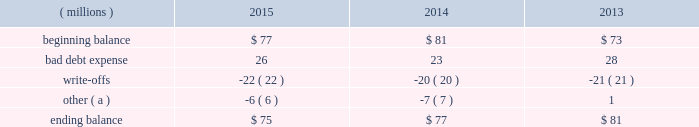Concentration of credit risk credit risk represents the accounting loss that would be recognized at the reporting date if counterparties failed to perform as contracted .
The company believes the likelihood of incurring material losses due to concentration of credit risk is remote .
The principal financial instruments subject to credit risk are as follows : cash and cash equivalents - the company maintains cash deposits with major banks , which from time to time may exceed insured limits .
The possibility of loss related to financial condition of major banks has been deemed minimal .
Additionally , the company 2019s investment policy limits exposure to concentrations of credit risk and changes in market conditions .
Accounts receivable - a large number of customers in diverse industries and geographies , as well as the practice of establishing reasonable credit lines , limits credit risk .
Based on historical trends and experiences , the allowance for doubtful accounts is adequate to cover potential credit risk losses .
Foreign currency and interest rate contracts and derivatives - exposure to credit risk is limited by internal policies and active monitoring of counterparty risks .
In addition , the company uses a diversified group of major international banks and financial institutions as counterparties .
The company does not anticipate nonperformance by any of these counterparties .
Cash and cash equivalents cash equivalents include highly-liquid investments with a maturity of three months or less when purchased .
Accounts receivable and allowance for doubtful accounts accounts receivable are carried at their face amounts less an allowance for doubtful accounts .
Accounts receivable are recorded at the invoiced amount and generally do not bear interest .
The company estimates the balance of allowance for doubtful accounts by analyzing accounts receivable balances by age and applying historical write-off and collection trend rates .
The company 2019s estimates include separately providing for customer balances based on specific circumstances and credit conditions , and when it is deemed probable that the balance is uncollectible .
Account balances are charged off against the allowance when it is determined the receivable will not be recovered .
The company 2019s allowance for doubtful accounts balance also includes an allowance for the expected return of products shipped and credits related to pricing or quantities shipped of $ 15 million as of december 31 , 2015 and 2014 and $ 14 million as of december 31 , 2013 .
Returns and credit activity is recorded directly to sales .
The table summarizes the activity in the allowance for doubtful accounts: .
( a ) other amounts are primarily the effects of changes in currency translations and the impact of allowance for returns and credits .
Inventory valuations inventories are valued at the lower of cost or market .
Certain u.s .
Inventory costs are determined on a last-in , first-out ( lifo ) basis .
Lifo inventories represented 39% ( 39 % ) and 37% ( 37 % ) of consolidated inventories as of december 31 , 2015 and 2014 , respectively .
Lifo inventories include certain legacy nalco u.s .
Inventory acquired at fair value as part of the nalco merger .
All other inventory costs are determined using either the average cost or first-in , first-out ( fifo ) methods .
Inventory values at fifo , as shown in note 5 , approximate replacement during the fourth quarter of 2015 , the company improved estimates related to its inventory reserves and product costing , resulting in a net pre-tax charge of approximately $ 6 million .
Separately , the actions resulted in charge of $ 20.6 million related to inventory reserve calculations , partially offset by a gain of $ 14.5 million related to the capitalization of certain cost components into inventory .
Both of these items are reflected in note 3. .
The company 2019s allowance for the expected return of products shipped and credits related to pricing or quantities shipped as of december 31 , 2015 , is what percent of the total 2015 ending balance? 
Computations: (15 / 75)
Answer: 0.2. 